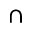Convert formula to latex. <formula><loc_0><loc_0><loc_500><loc_500>\cap</formula> 